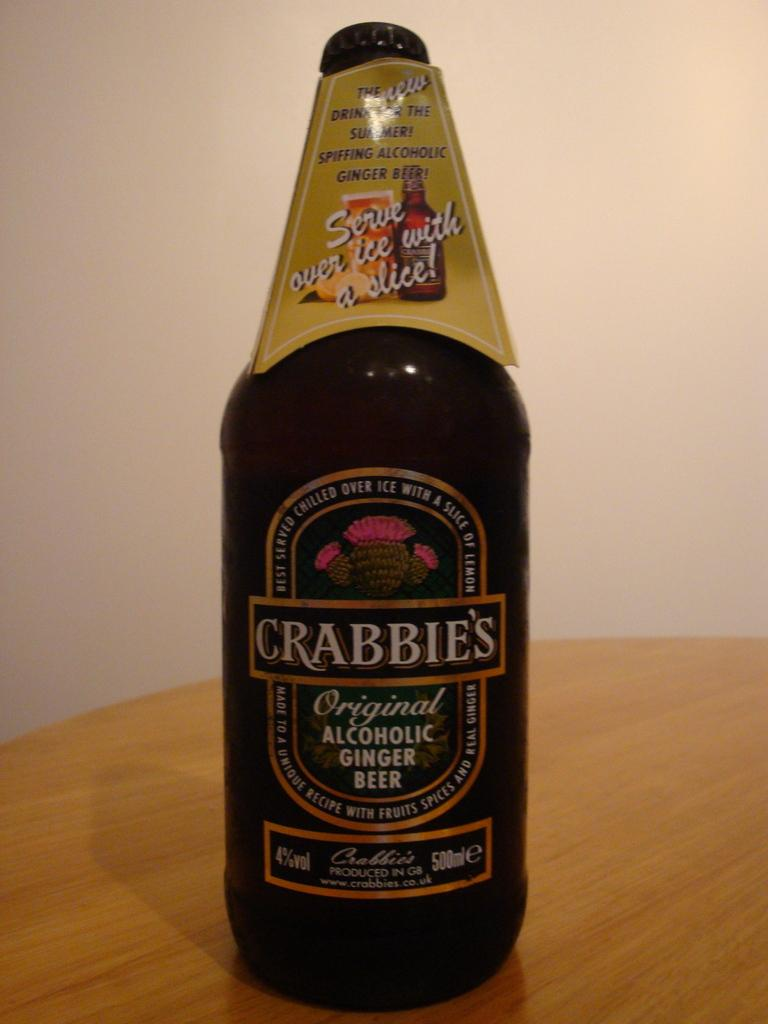<image>
Provide a brief description of the given image. A bottle of Crabbies ginger beer is on a table. 